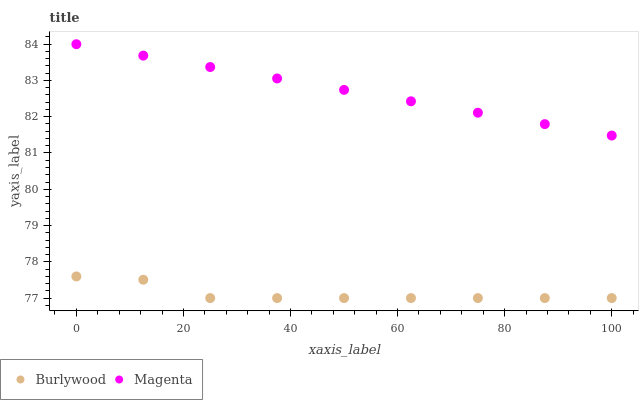Does Burlywood have the minimum area under the curve?
Answer yes or no. Yes. Does Magenta have the maximum area under the curve?
Answer yes or no. Yes. Does Magenta have the minimum area under the curve?
Answer yes or no. No. Is Magenta the smoothest?
Answer yes or no. Yes. Is Burlywood the roughest?
Answer yes or no. Yes. Is Magenta the roughest?
Answer yes or no. No. Does Burlywood have the lowest value?
Answer yes or no. Yes. Does Magenta have the lowest value?
Answer yes or no. No. Does Magenta have the highest value?
Answer yes or no. Yes. Is Burlywood less than Magenta?
Answer yes or no. Yes. Is Magenta greater than Burlywood?
Answer yes or no. Yes. Does Burlywood intersect Magenta?
Answer yes or no. No. 